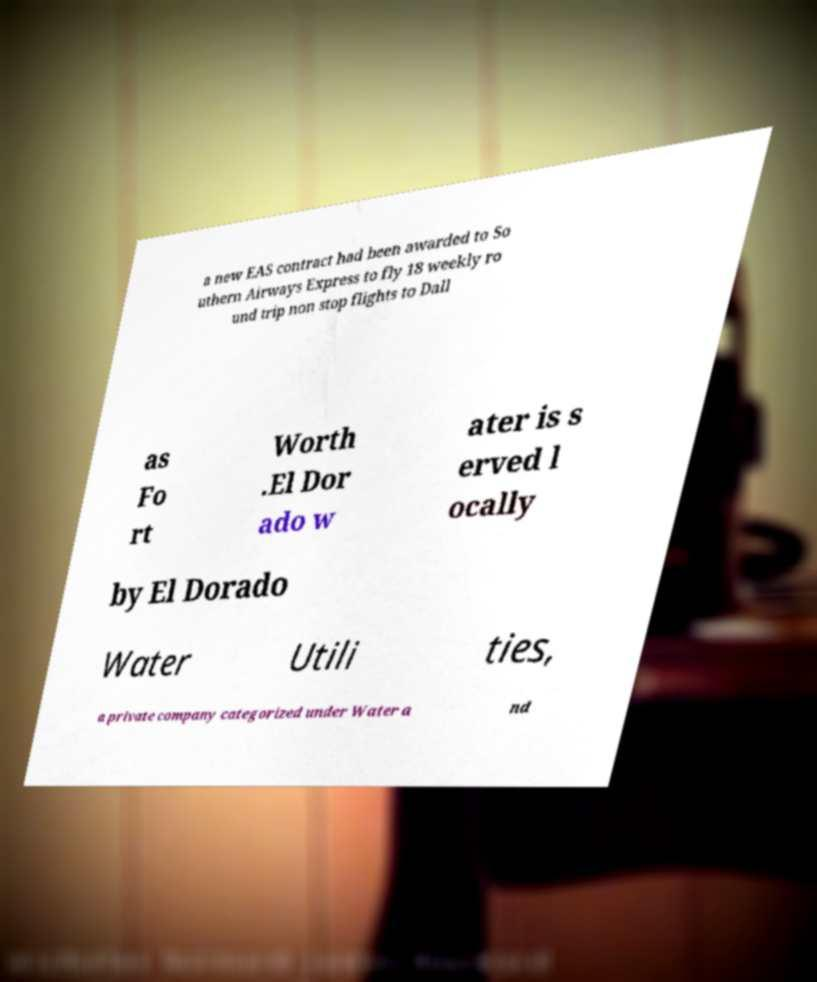What messages or text are displayed in this image? I need them in a readable, typed format. a new EAS contract had been awarded to So uthern Airways Express to fly 18 weekly ro und trip non stop flights to Dall as Fo rt Worth .El Dor ado w ater is s erved l ocally by El Dorado Water Utili ties, a private company categorized under Water a nd 